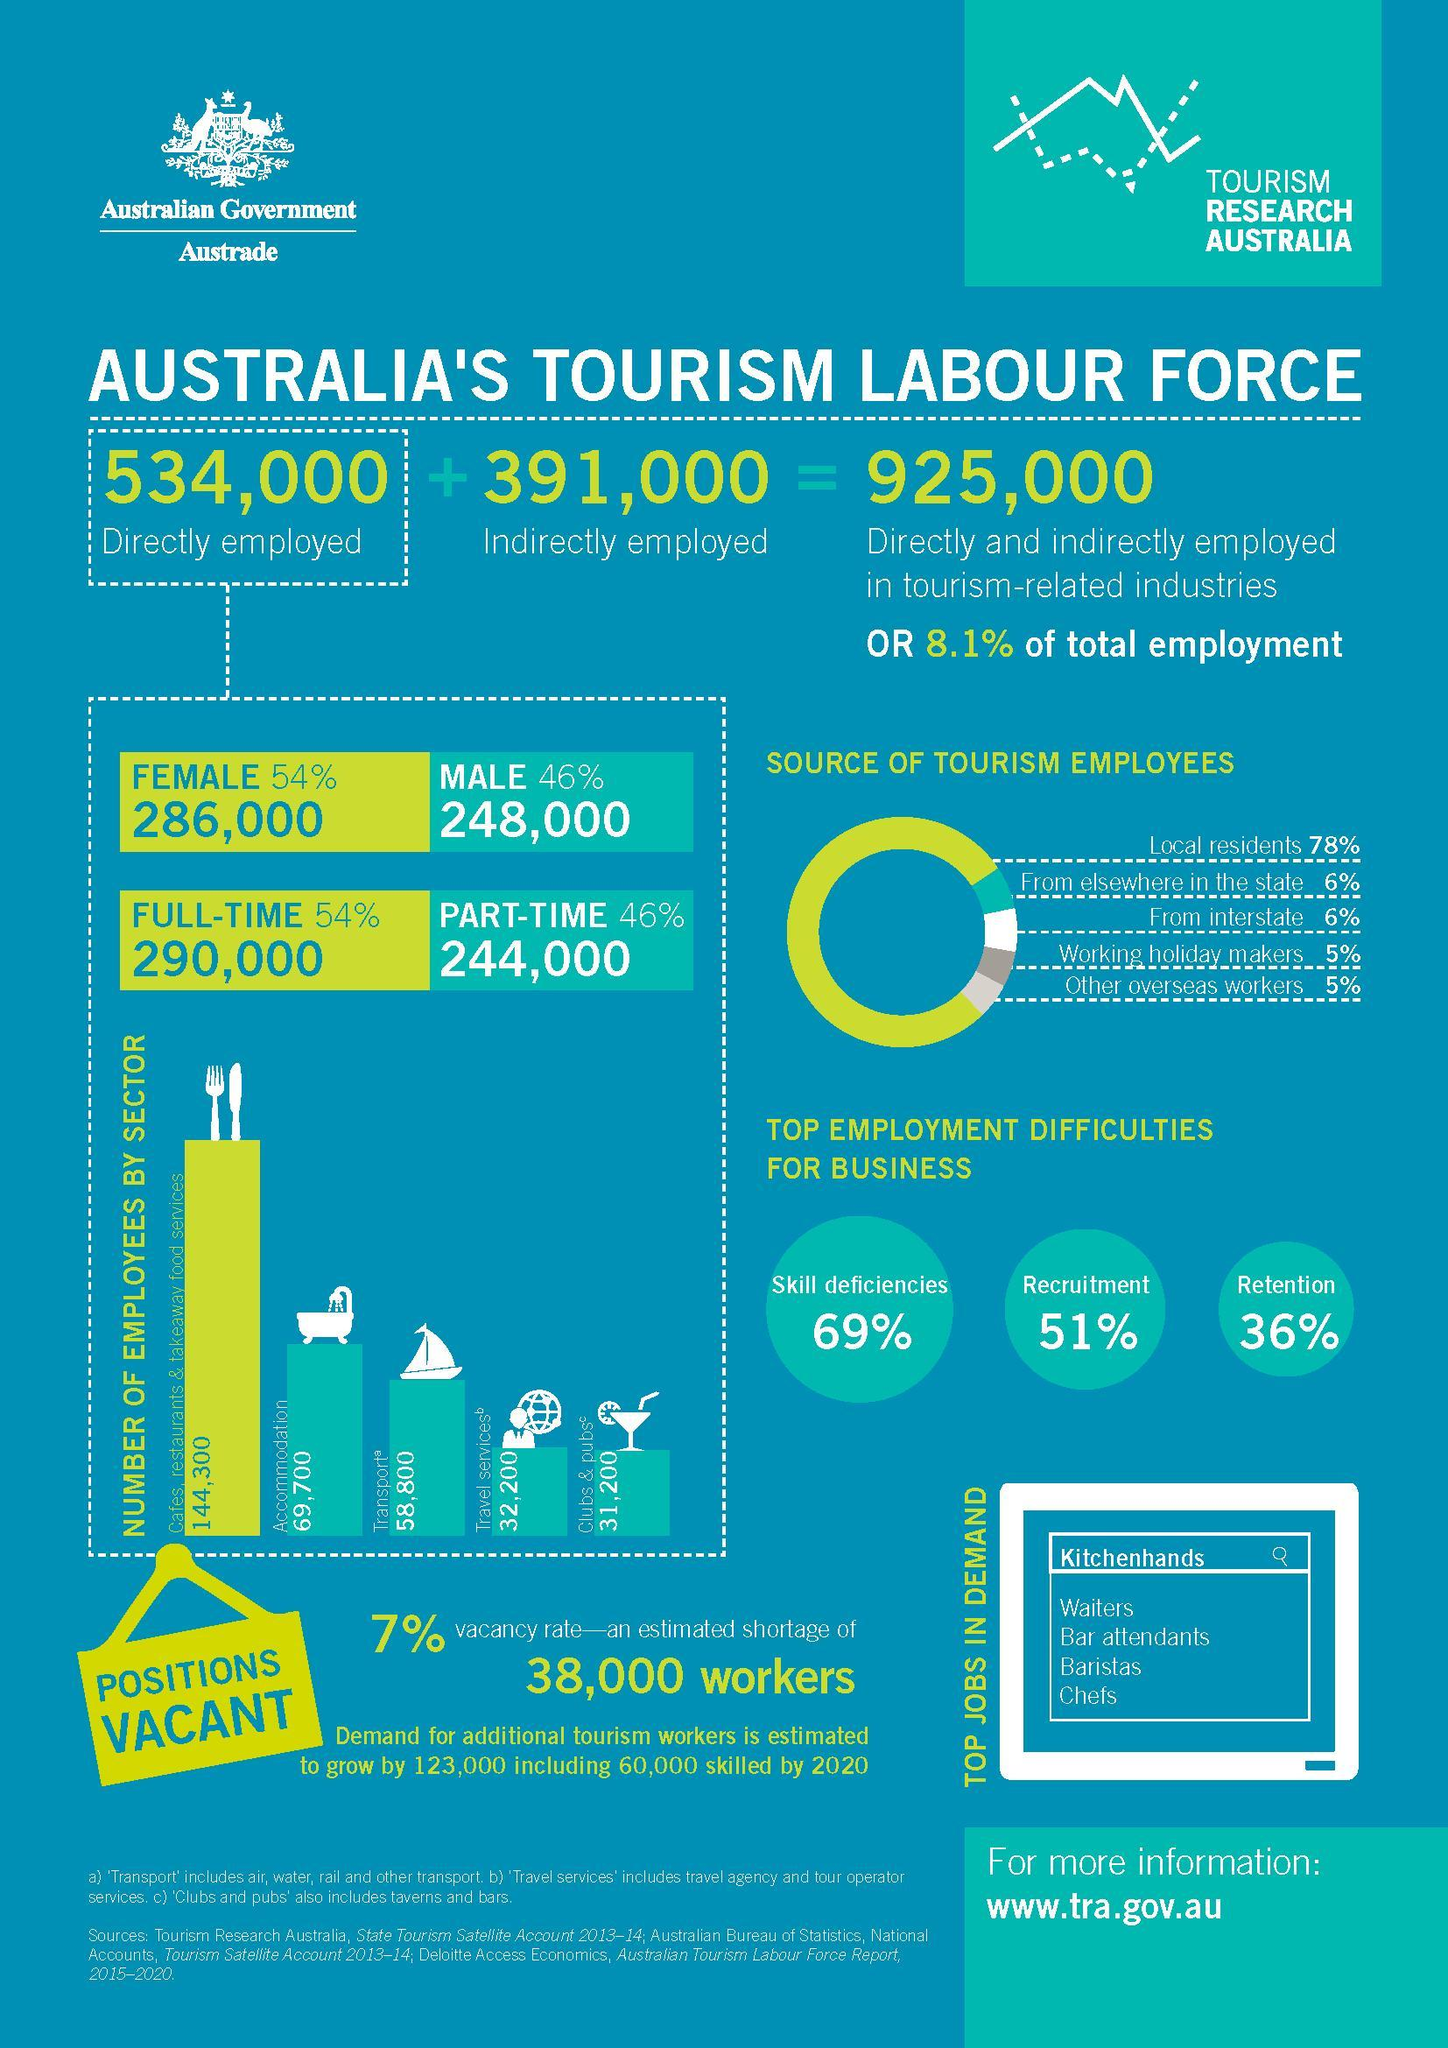how much less is the indirectly employed than the directly employed in tourism industry
Answer the question with a short phrase. 143000 employees from interstate is equal to employees from where from elsewhere in the state employees from working holiday makers is equal to employees from where other overseas workers how much more in percentage is the female employee than male employee 8 what is the number of employees in transport and travel services 91000 what is the count of full time employees 290,000 